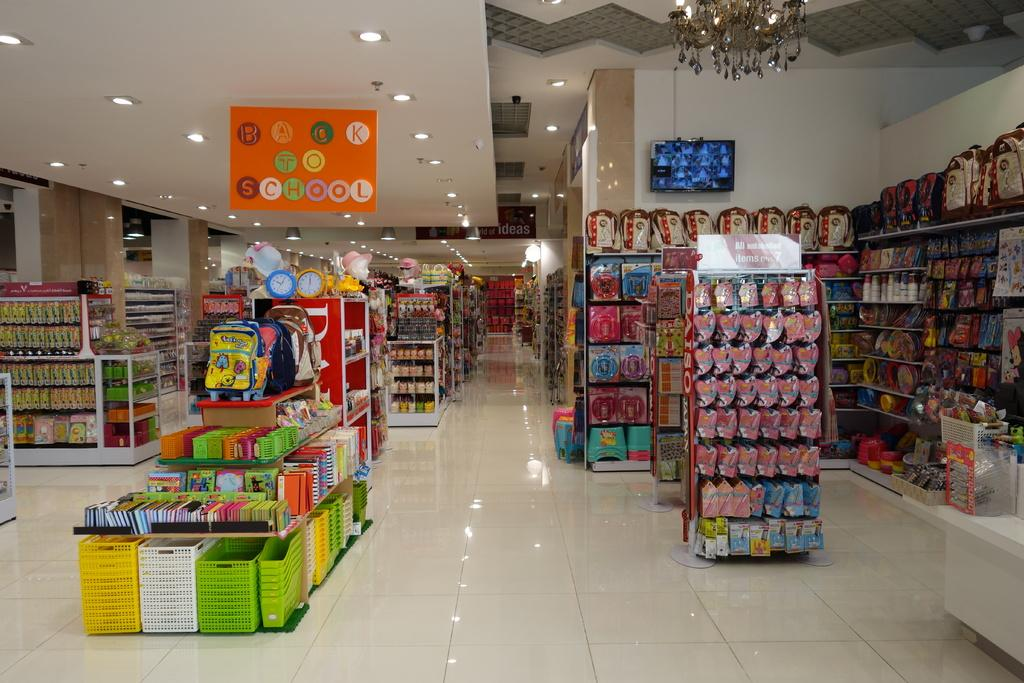<image>
Create a compact narrative representing the image presented. A convenience store is ready for Back to School savings 